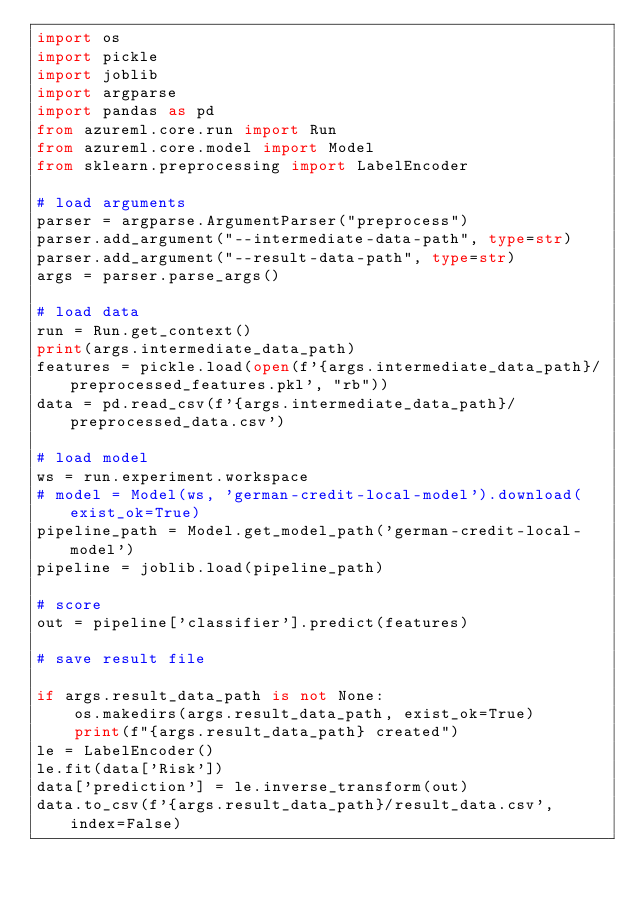<code> <loc_0><loc_0><loc_500><loc_500><_Python_>import os
import pickle
import joblib
import argparse
import pandas as pd
from azureml.core.run import Run
from azureml.core.model import Model
from sklearn.preprocessing import LabelEncoder

# load arguments
parser = argparse.ArgumentParser("preprocess")
parser.add_argument("--intermediate-data-path", type=str)
parser.add_argument("--result-data-path", type=str)
args = parser.parse_args()

# load data
run = Run.get_context()
print(args.intermediate_data_path)
features = pickle.load(open(f'{args.intermediate_data_path}/preprocessed_features.pkl', "rb"))
data = pd.read_csv(f'{args.intermediate_data_path}/preprocessed_data.csv')

# load model
ws = run.experiment.workspace
# model = Model(ws, 'german-credit-local-model').download(exist_ok=True)
pipeline_path = Model.get_model_path('german-credit-local-model')
pipeline = joblib.load(pipeline_path)

# score
out = pipeline['classifier'].predict(features)

# save result file

if args.result_data_path is not None:
    os.makedirs(args.result_data_path, exist_ok=True)
    print(f"{args.result_data_path} created")
le = LabelEncoder()
le.fit(data['Risk'])
data['prediction'] = le.inverse_transform(out)
data.to_csv(f'{args.result_data_path}/result_data.csv', index=False)</code> 